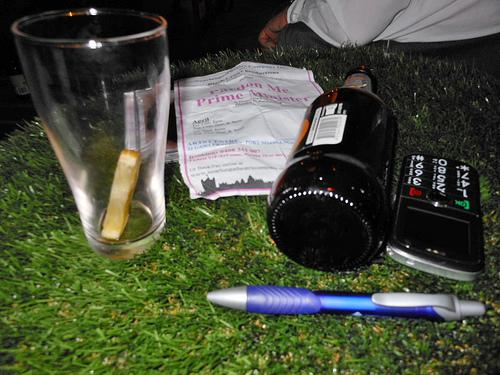Question: where are these item laying?
Choices:
A. In the sand.
B. In the snow.
C. On a fake grass top table.
D. On a bed.
Answer with the letter. Answer: C Question: how did the pen get there?
Choices:
A. It fell down.
B. The person taking the picture left it.
C. It rolled.
D. The child took it.
Answer with the letter. Answer: B 